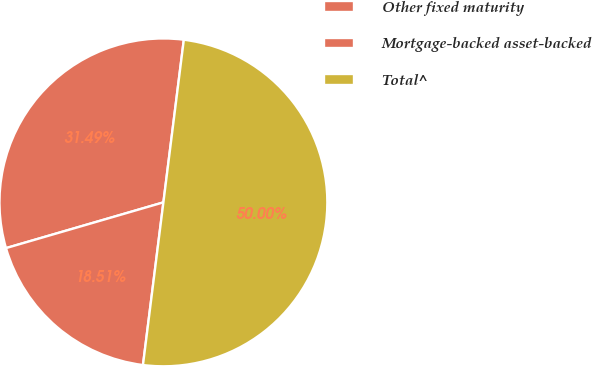Convert chart to OTSL. <chart><loc_0><loc_0><loc_500><loc_500><pie_chart><fcel>Other fixed maturity<fcel>Mortgage-backed asset-backed<fcel>Total^<nl><fcel>31.49%<fcel>18.51%<fcel>50.0%<nl></chart> 